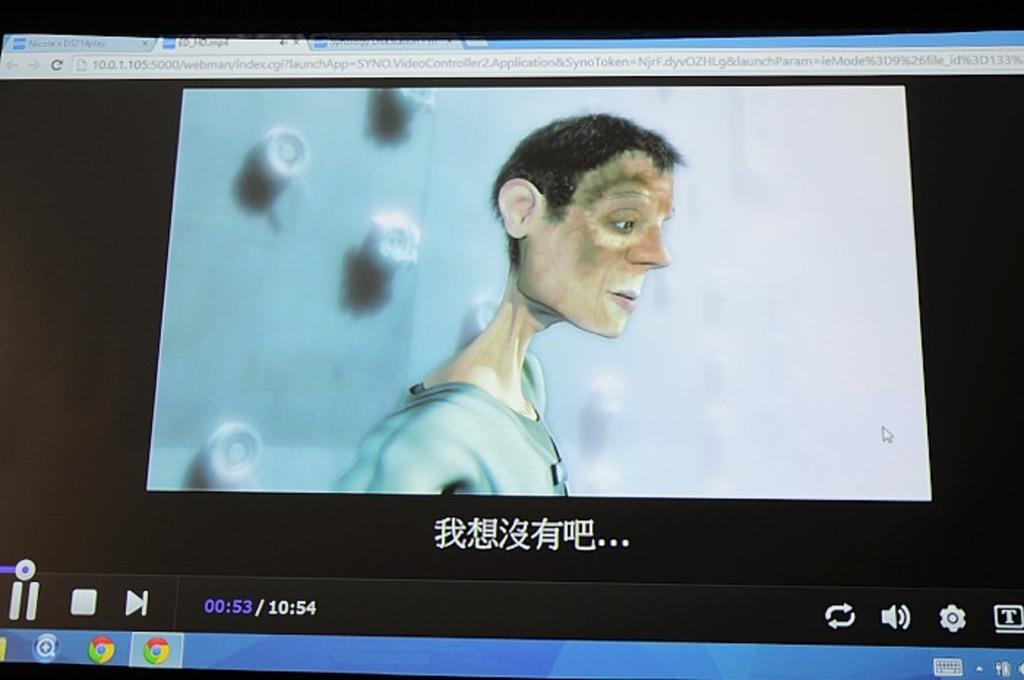What is the main object in the image? There is a monitor screen in the image. What can be seen on the monitor screen? There is an animated person visible on the monitor screen. What type of music is the worm playing on the heart in the image? There is no worm or heart present in the image; it only features a monitor screen with an animated person. 